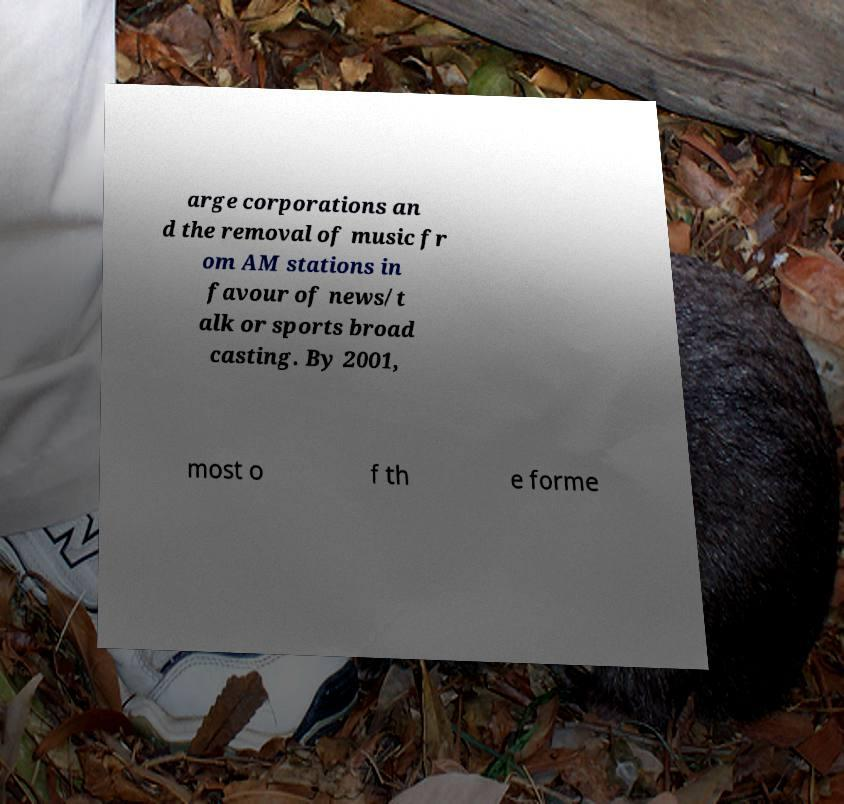Could you extract and type out the text from this image? arge corporations an d the removal of music fr om AM stations in favour of news/t alk or sports broad casting. By 2001, most o f th e forme 